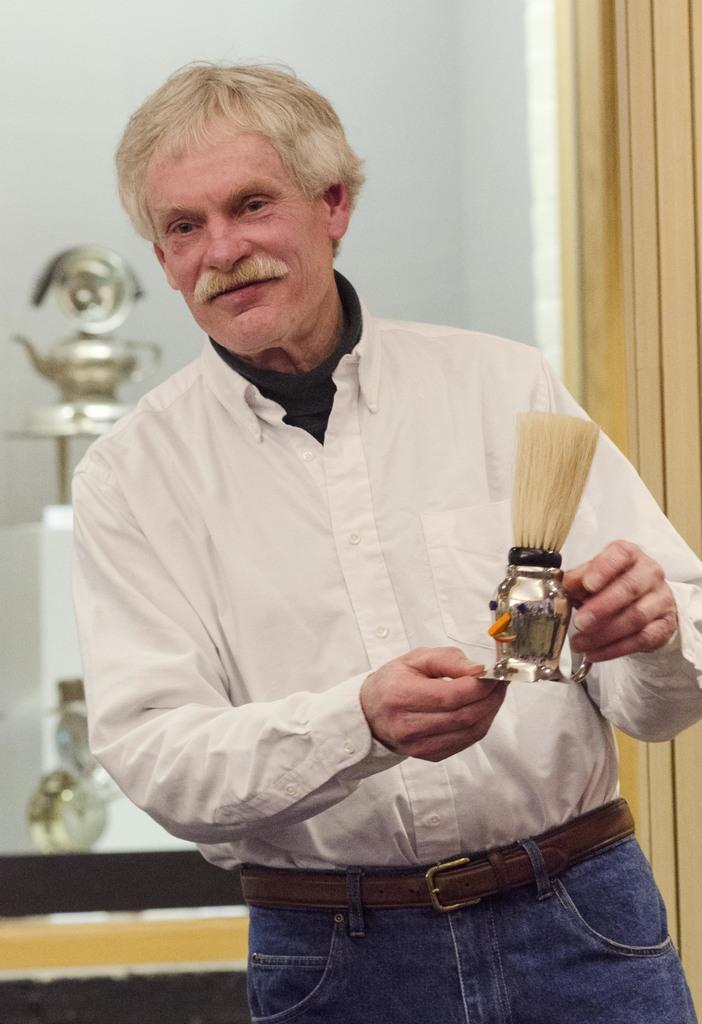What is present in the image? There is a man in the image. What is the man doing in the image? The man is holding an object in his hand. What can be seen in the background of the image? There is a door, a wall, and some equipment in the background of the image. Where is the image taken? The image is taken in a room. How many nests can be seen in the image? There are no nests present in the image. What type of comfort is provided by the equipment in the image? The image does not show any comfort provided by the equipment; it only shows the equipment in the background. 